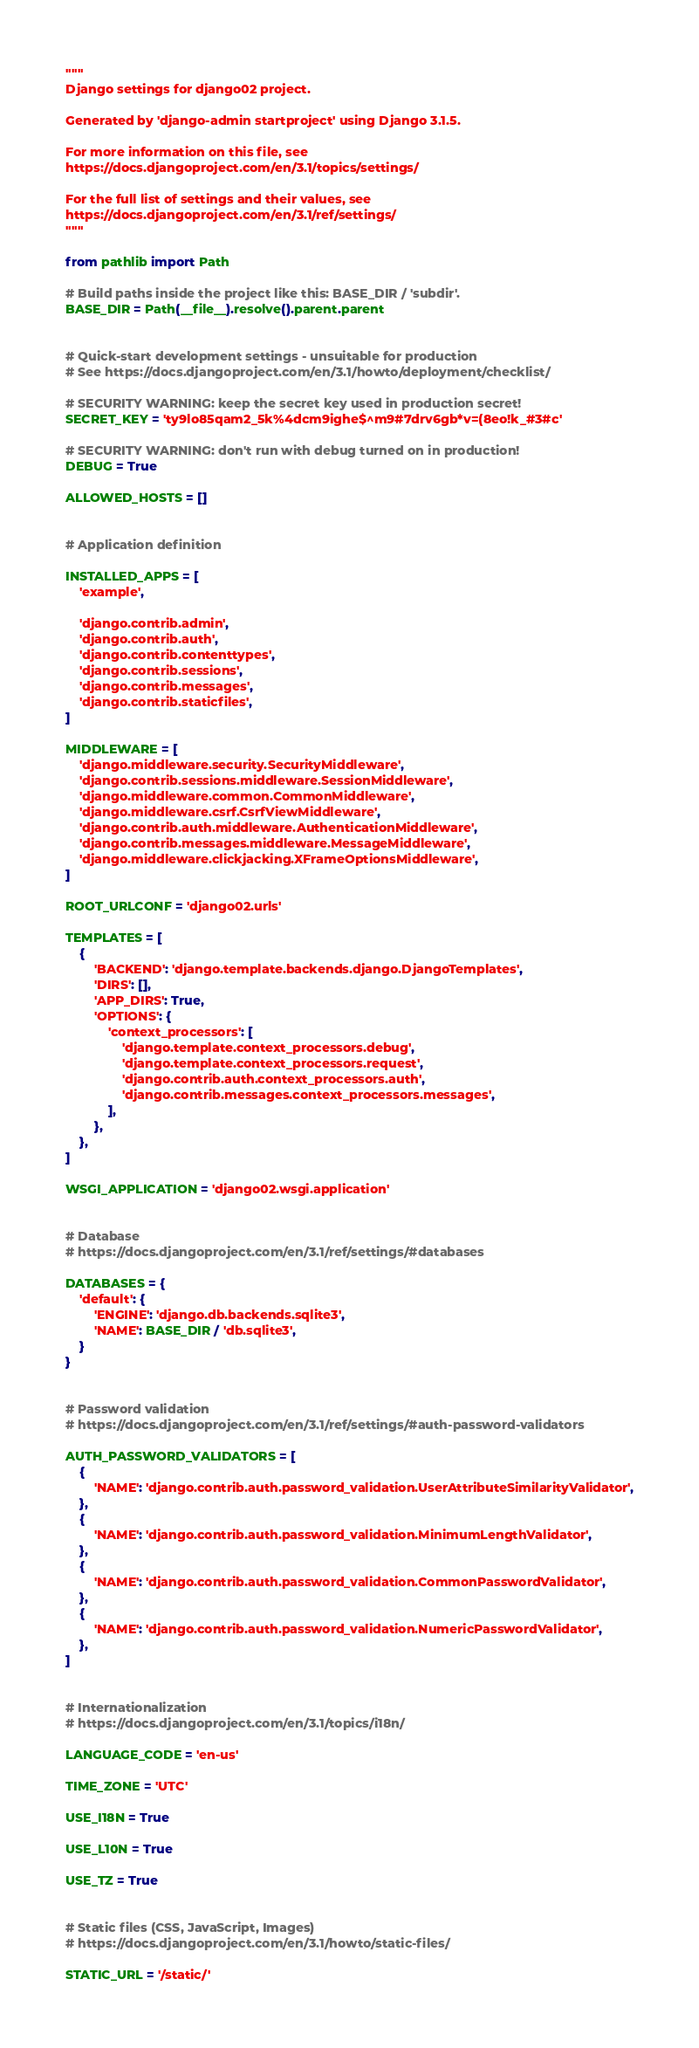<code> <loc_0><loc_0><loc_500><loc_500><_Python_>"""
Django settings for django02 project.

Generated by 'django-admin startproject' using Django 3.1.5.

For more information on this file, see
https://docs.djangoproject.com/en/3.1/topics/settings/

For the full list of settings and their values, see
https://docs.djangoproject.com/en/3.1/ref/settings/
"""

from pathlib import Path

# Build paths inside the project like this: BASE_DIR / 'subdir'.
BASE_DIR = Path(__file__).resolve().parent.parent


# Quick-start development settings - unsuitable for production
# See https://docs.djangoproject.com/en/3.1/howto/deployment/checklist/

# SECURITY WARNING: keep the secret key used in production secret!
SECRET_KEY = 'ty9lo85qam2_5k%4dcm9ighe$^m9#7drv6gb*v=(8eo!k_#3#c'

# SECURITY WARNING: don't run with debug turned on in production!
DEBUG = True

ALLOWED_HOSTS = []


# Application definition

INSTALLED_APPS = [
    'example',
    
    'django.contrib.admin',
    'django.contrib.auth',
    'django.contrib.contenttypes',
    'django.contrib.sessions',
    'django.contrib.messages',
    'django.contrib.staticfiles',
]

MIDDLEWARE = [
    'django.middleware.security.SecurityMiddleware',
    'django.contrib.sessions.middleware.SessionMiddleware',
    'django.middleware.common.CommonMiddleware',
    'django.middleware.csrf.CsrfViewMiddleware',
    'django.contrib.auth.middleware.AuthenticationMiddleware',
    'django.contrib.messages.middleware.MessageMiddleware',
    'django.middleware.clickjacking.XFrameOptionsMiddleware',
]

ROOT_URLCONF = 'django02.urls'

TEMPLATES = [
    {
        'BACKEND': 'django.template.backends.django.DjangoTemplates',
        'DIRS': [],
        'APP_DIRS': True,
        'OPTIONS': {
            'context_processors': [
                'django.template.context_processors.debug',
                'django.template.context_processors.request',
                'django.contrib.auth.context_processors.auth',
                'django.contrib.messages.context_processors.messages',
            ],
        },
    },
]

WSGI_APPLICATION = 'django02.wsgi.application'


# Database
# https://docs.djangoproject.com/en/3.1/ref/settings/#databases

DATABASES = {
    'default': {
        'ENGINE': 'django.db.backends.sqlite3',
        'NAME': BASE_DIR / 'db.sqlite3',
    }
}


# Password validation
# https://docs.djangoproject.com/en/3.1/ref/settings/#auth-password-validators

AUTH_PASSWORD_VALIDATORS = [
    {
        'NAME': 'django.contrib.auth.password_validation.UserAttributeSimilarityValidator',
    },
    {
        'NAME': 'django.contrib.auth.password_validation.MinimumLengthValidator',
    },
    {
        'NAME': 'django.contrib.auth.password_validation.CommonPasswordValidator',
    },
    {
        'NAME': 'django.contrib.auth.password_validation.NumericPasswordValidator',
    },
]


# Internationalization
# https://docs.djangoproject.com/en/3.1/topics/i18n/

LANGUAGE_CODE = 'en-us'

TIME_ZONE = 'UTC'

USE_I18N = True

USE_L10N = True

USE_TZ = True


# Static files (CSS, JavaScript, Images)
# https://docs.djangoproject.com/en/3.1/howto/static-files/

STATIC_URL = '/static/'
</code> 